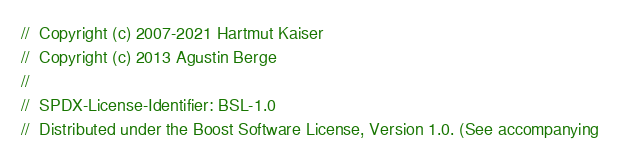<code> <loc_0><loc_0><loc_500><loc_500><_C++_>//  Copyright (c) 2007-2021 Hartmut Kaiser
//  Copyright (c) 2013 Agustin Berge
//
//  SPDX-License-Identifier: BSL-1.0
//  Distributed under the Boost Software License, Version 1.0. (See accompanying</code> 